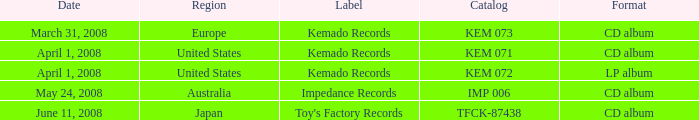Which Format has a Label of toy's factory records? CD album. 